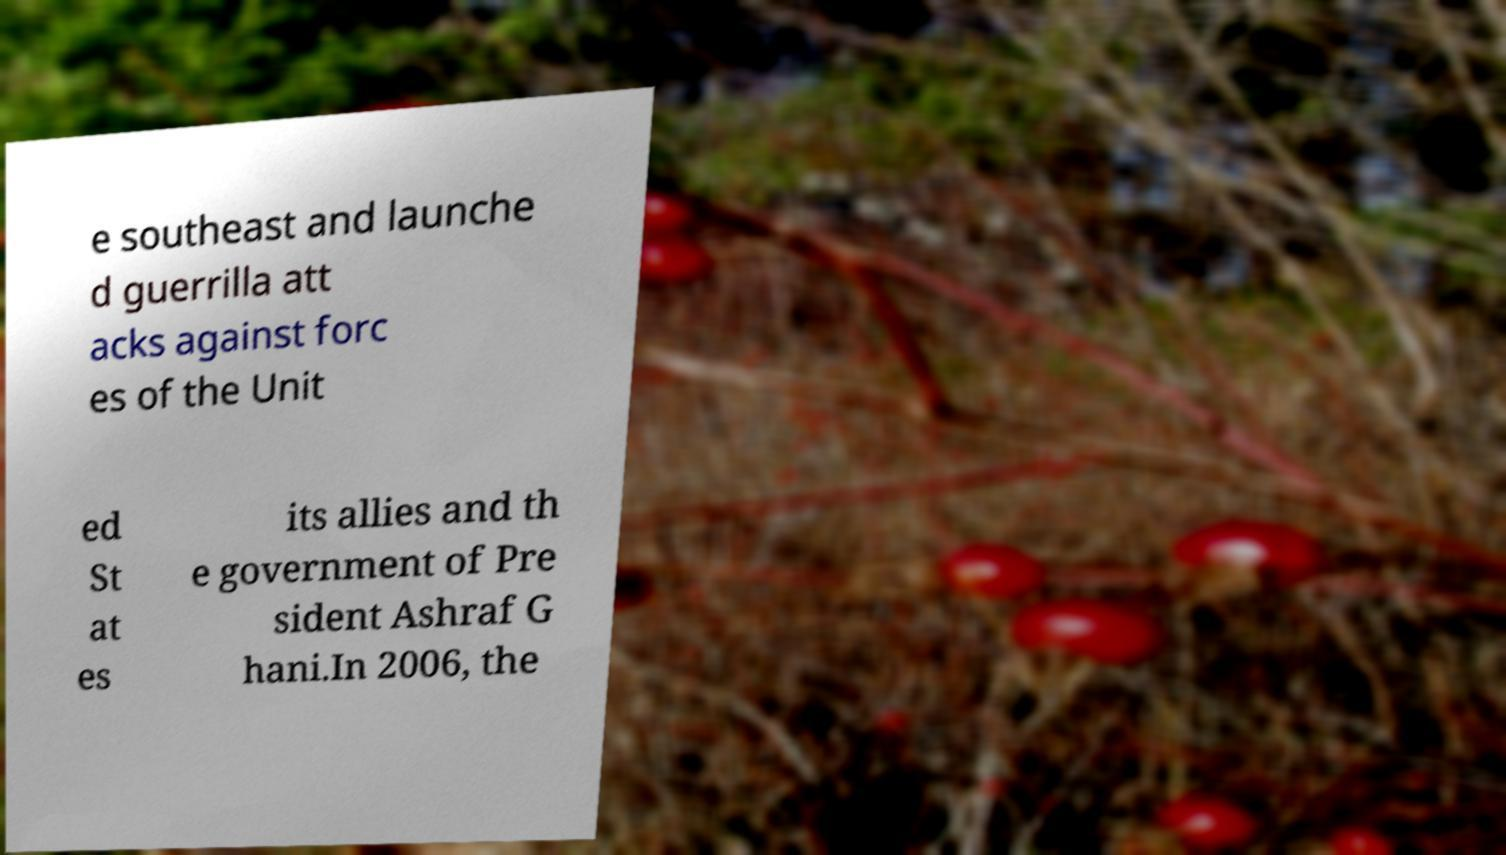For documentation purposes, I need the text within this image transcribed. Could you provide that? e southeast and launche d guerrilla att acks against forc es of the Unit ed St at es its allies and th e government of Pre sident Ashraf G hani.In 2006, the 